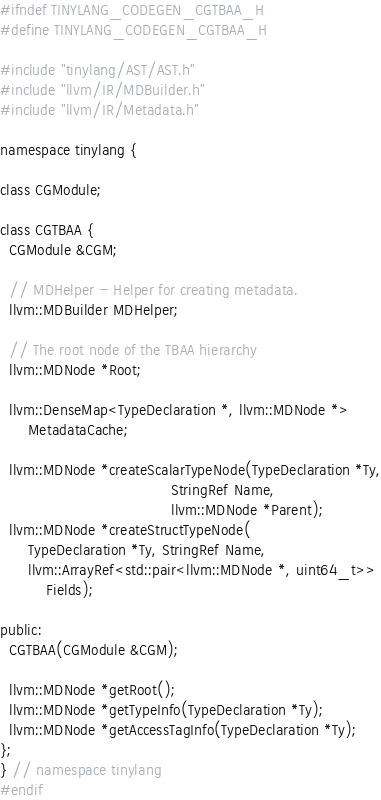<code> <loc_0><loc_0><loc_500><loc_500><_C_>#ifndef TINYLANG_CODEGEN_CGTBAA_H
#define TINYLANG_CODEGEN_CGTBAA_H

#include "tinylang/AST/AST.h"
#include "llvm/IR/MDBuilder.h"
#include "llvm/IR/Metadata.h"

namespace tinylang {

class CGModule;

class CGTBAA {
  CGModule &CGM;

  // MDHelper - Helper for creating metadata.
  llvm::MDBuilder MDHelper;

  // The root node of the TBAA hierarchy
  llvm::MDNode *Root;

  llvm::DenseMap<TypeDeclaration *, llvm::MDNode *>
      MetadataCache;

  llvm::MDNode *createScalarTypeNode(TypeDeclaration *Ty,
                                     StringRef Name,
                                     llvm::MDNode *Parent);
  llvm::MDNode *createStructTypeNode(
      TypeDeclaration *Ty, StringRef Name,
      llvm::ArrayRef<std::pair<llvm::MDNode *, uint64_t>>
          Fields);

public:
  CGTBAA(CGModule &CGM);

  llvm::MDNode *getRoot();
  llvm::MDNode *getTypeInfo(TypeDeclaration *Ty);
  llvm::MDNode *getAccessTagInfo(TypeDeclaration *Ty);
};
} // namespace tinylang
#endif</code> 